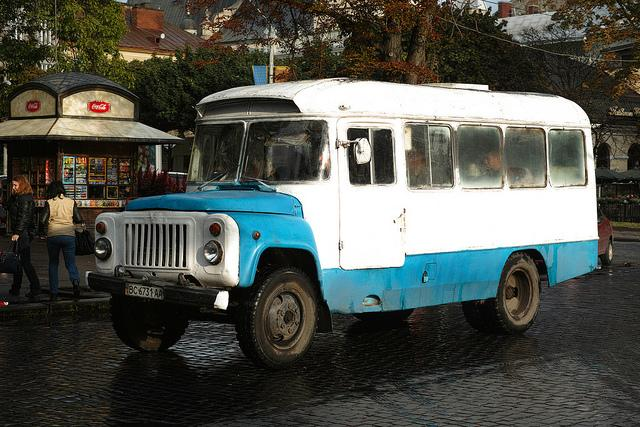What part of the bus needs good traction to ride safely? tires 